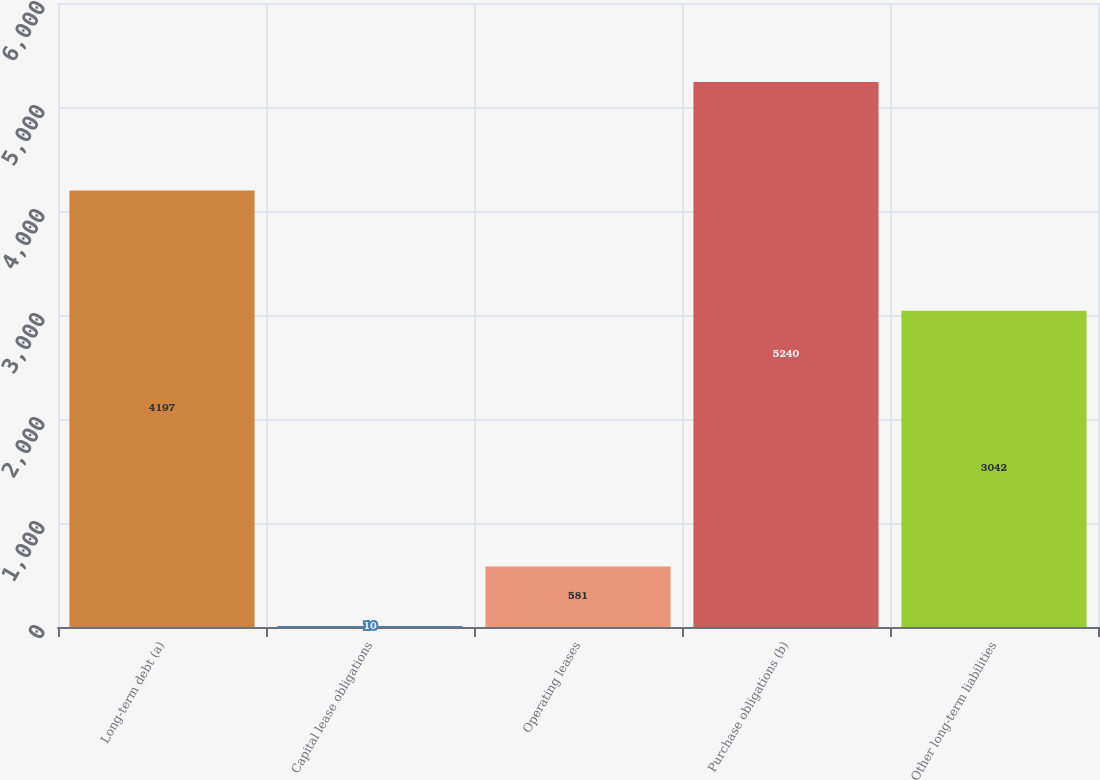Convert chart. <chart><loc_0><loc_0><loc_500><loc_500><bar_chart><fcel>Long-term debt (a)<fcel>Capital lease obligations<fcel>Operating leases<fcel>Purchase obligations (b)<fcel>Other long-term liabilities<nl><fcel>4197<fcel>10<fcel>581<fcel>5240<fcel>3042<nl></chart> 